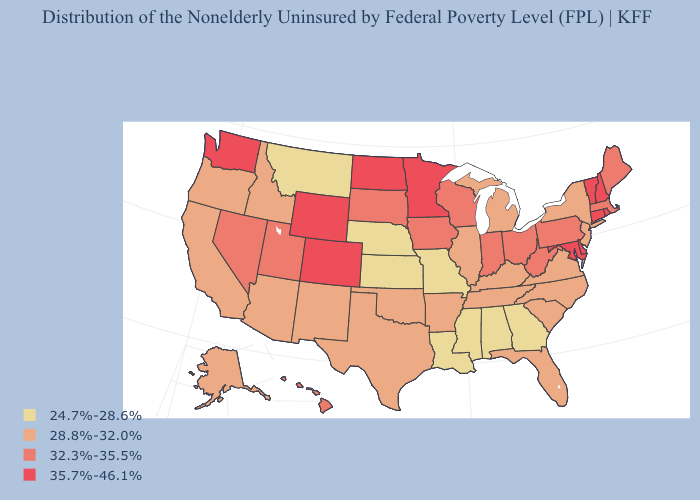Which states have the highest value in the USA?
Quick response, please. Colorado, Connecticut, Delaware, Maryland, Minnesota, New Hampshire, North Dakota, Rhode Island, Vermont, Washington, Wyoming. What is the value of Missouri?
Concise answer only. 24.7%-28.6%. Which states have the lowest value in the USA?
Keep it brief. Alabama, Georgia, Kansas, Louisiana, Mississippi, Missouri, Montana, Nebraska. What is the value of Missouri?
Be succinct. 24.7%-28.6%. Name the states that have a value in the range 32.3%-35.5%?
Short answer required. Hawaii, Indiana, Iowa, Maine, Massachusetts, Nevada, Ohio, Pennsylvania, South Dakota, Utah, West Virginia, Wisconsin. Name the states that have a value in the range 32.3%-35.5%?
Quick response, please. Hawaii, Indiana, Iowa, Maine, Massachusetts, Nevada, Ohio, Pennsylvania, South Dakota, Utah, West Virginia, Wisconsin. What is the lowest value in the South?
Quick response, please. 24.7%-28.6%. Does the first symbol in the legend represent the smallest category?
Quick response, please. Yes. What is the value of Indiana?
Be succinct. 32.3%-35.5%. What is the value of New Hampshire?
Give a very brief answer. 35.7%-46.1%. Does North Dakota have the highest value in the USA?
Write a very short answer. Yes. Is the legend a continuous bar?
Give a very brief answer. No. Does South Dakota have the same value as Iowa?
Short answer required. Yes. Among the states that border New Mexico , which have the lowest value?
Write a very short answer. Arizona, Oklahoma, Texas. Name the states that have a value in the range 28.8%-32.0%?
Quick response, please. Alaska, Arizona, Arkansas, California, Florida, Idaho, Illinois, Kentucky, Michigan, New Jersey, New Mexico, New York, North Carolina, Oklahoma, Oregon, South Carolina, Tennessee, Texas, Virginia. 